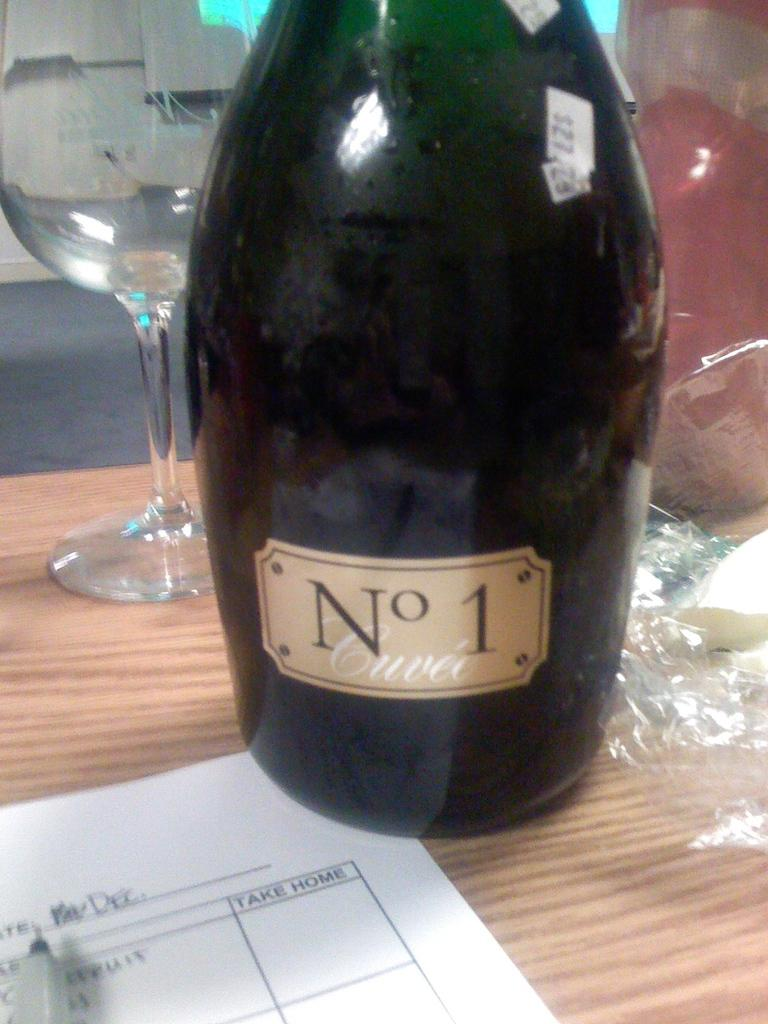<image>
Share a concise interpretation of the image provided. A bottle of alcohol called No 1 which is beside a tall glass. 